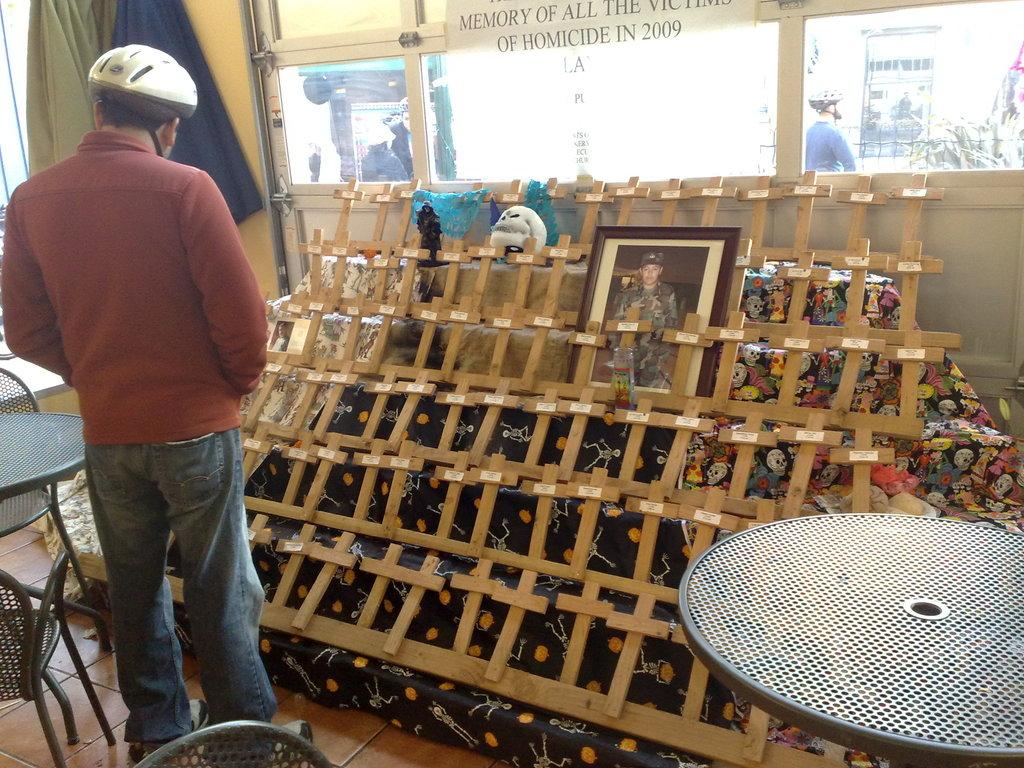What type of furniture is present in the image? There are chairs and tables in the image. Can you describe the people in the image? There are people in the image. What material are the wooden sticks made of? The wooden sticks in the image are made of wood. What is the purpose of the photo frame in the image? The photo frame in the image is likely used for displaying a photograph or artwork. Where are the stairs located in the image? The stairs are present in the image. What other objects can be seen in the image besides the ones mentioned? There are other objects in the image. What type of popcorn is being served on the scale in the image? There is no scale or popcorn present in the image. Who is wearing the crown in the image? There is no crown or person wearing a crown in the image. 